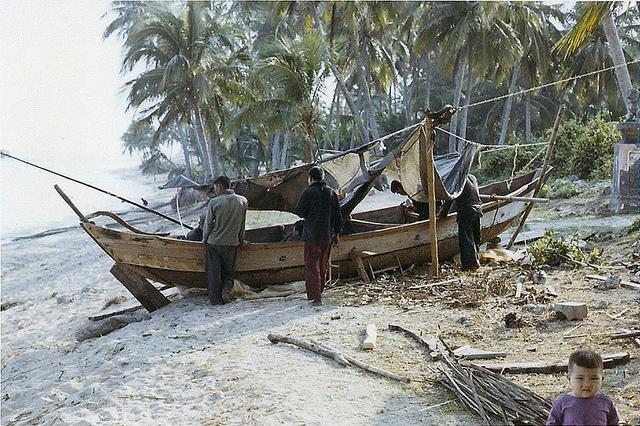Who is in the front right corner?

Choices:
A) old woman
B) little child
C) old man
D) school teacher little child 